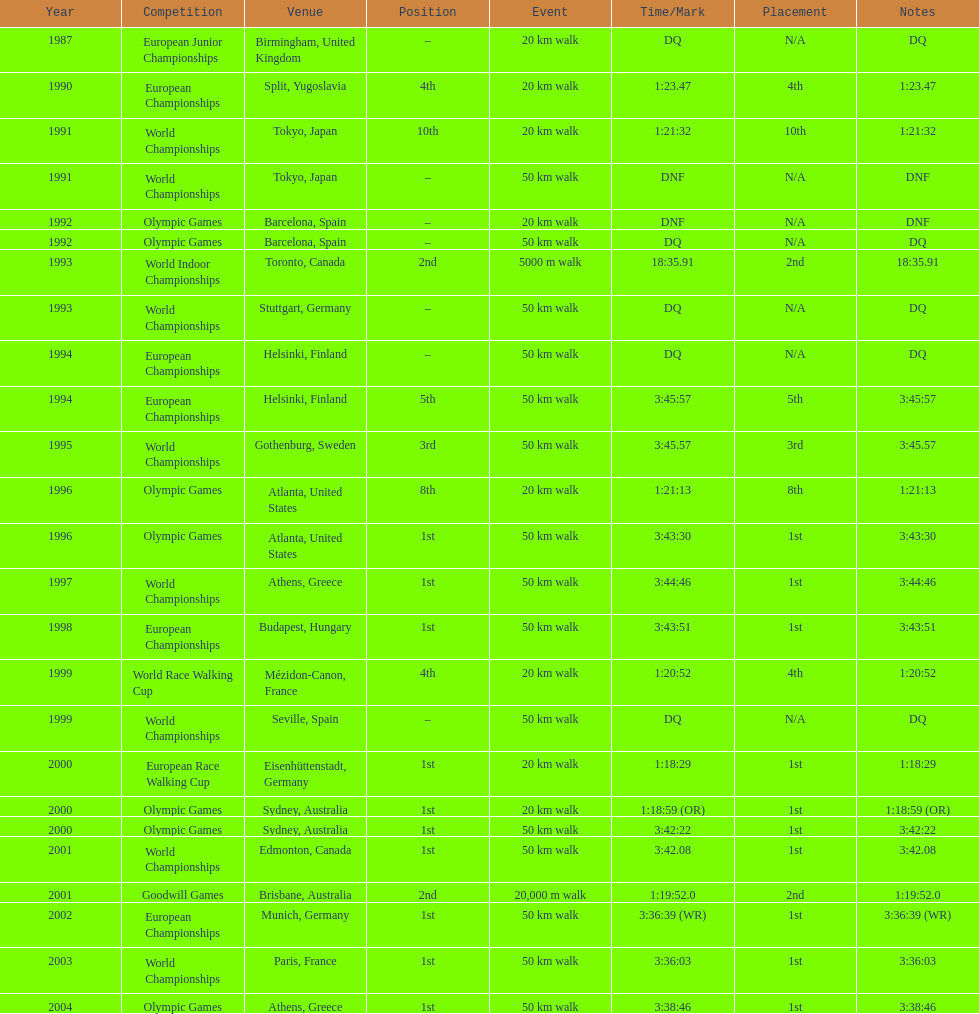In what year was korzeniowski's last competition? 2004. 